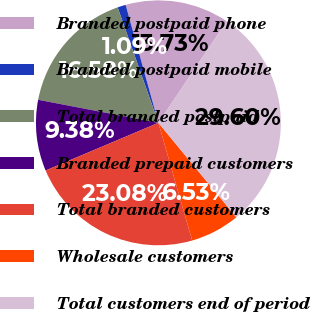Convert chart to OTSL. <chart><loc_0><loc_0><loc_500><loc_500><pie_chart><fcel>Branded postpaid phone<fcel>Branded postpaid mobile<fcel>Total branded postpaid<fcel>Branded prepaid customers<fcel>Total branded customers<fcel>Wholesale customers<fcel>Total customers end of period<nl><fcel>13.73%<fcel>1.09%<fcel>16.58%<fcel>9.38%<fcel>23.08%<fcel>6.53%<fcel>29.6%<nl></chart> 